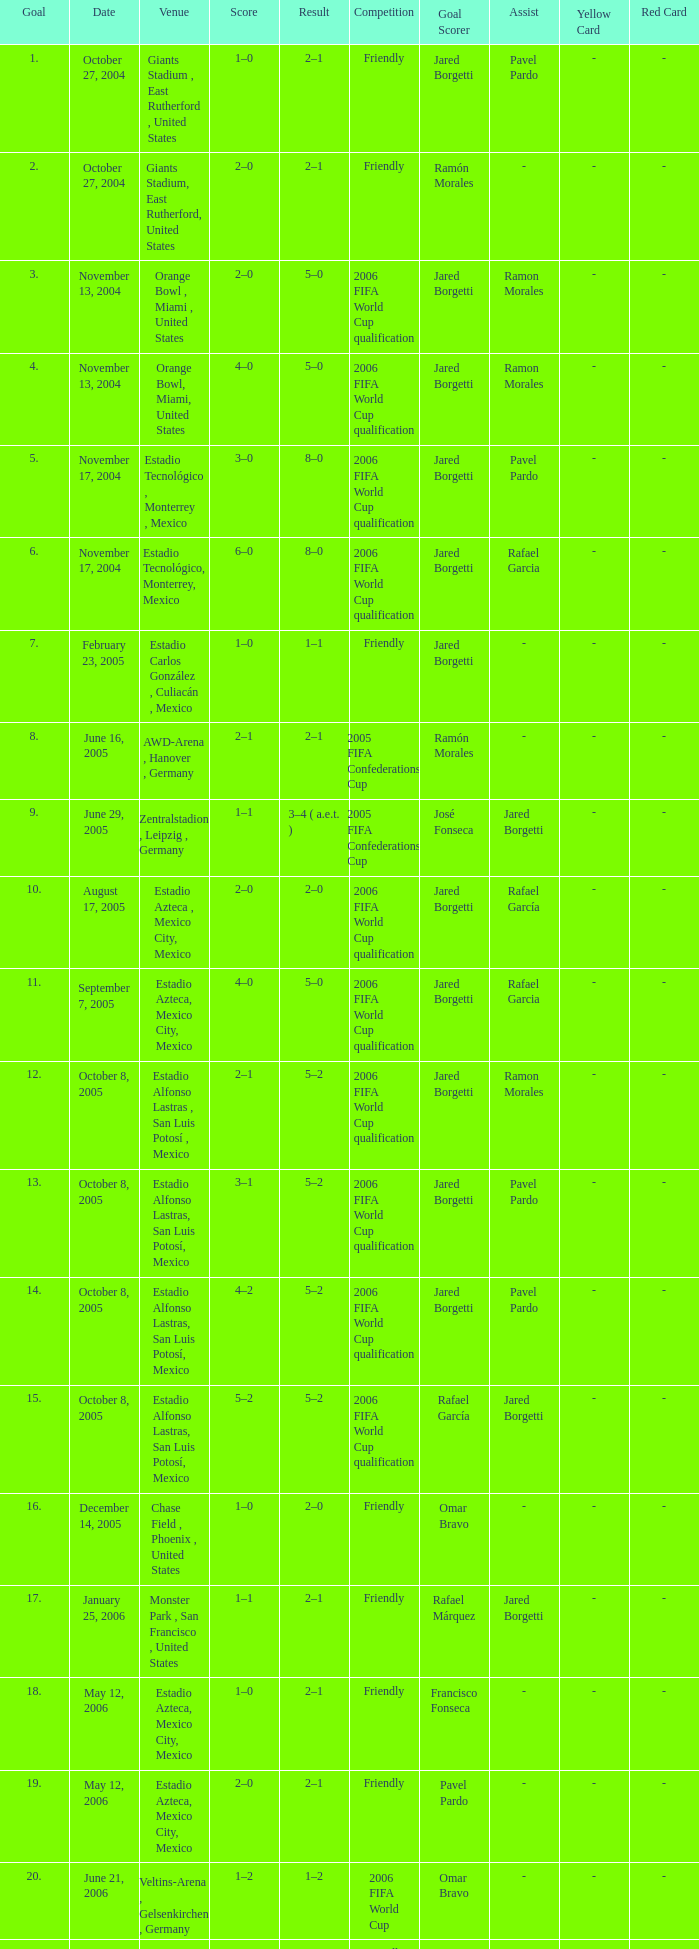Which Score has a Date of october 8, 2005, and a Venue of estadio alfonso lastras, san luis potosí, mexico? 2–1, 3–1, 4–2, 5–2. 